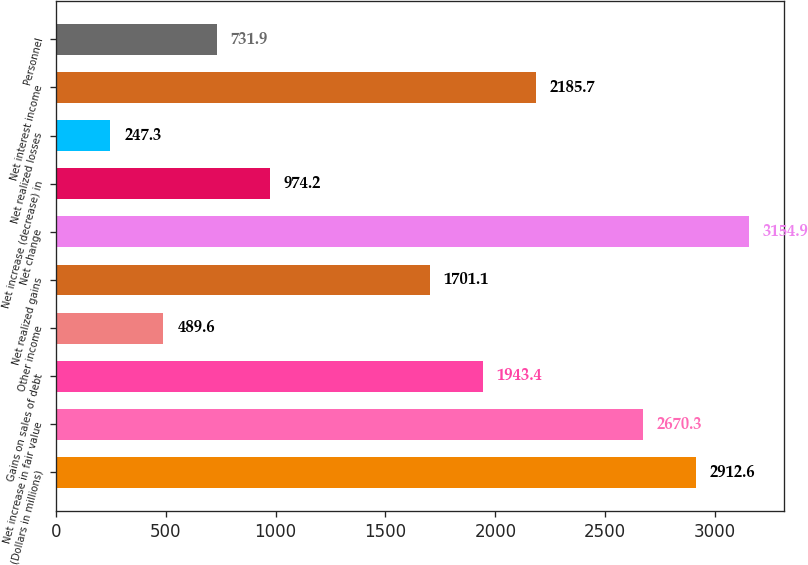Convert chart. <chart><loc_0><loc_0><loc_500><loc_500><bar_chart><fcel>(Dollars in millions)<fcel>Net increase in fair value<fcel>Gains on sales of debt<fcel>Other income<fcel>Net realized gains<fcel>Net change<fcel>Net increase (decrease) in<fcel>Net realized losses<fcel>Net interest income<fcel>Personnel<nl><fcel>2912.6<fcel>2670.3<fcel>1943.4<fcel>489.6<fcel>1701.1<fcel>3154.9<fcel>974.2<fcel>247.3<fcel>2185.7<fcel>731.9<nl></chart> 